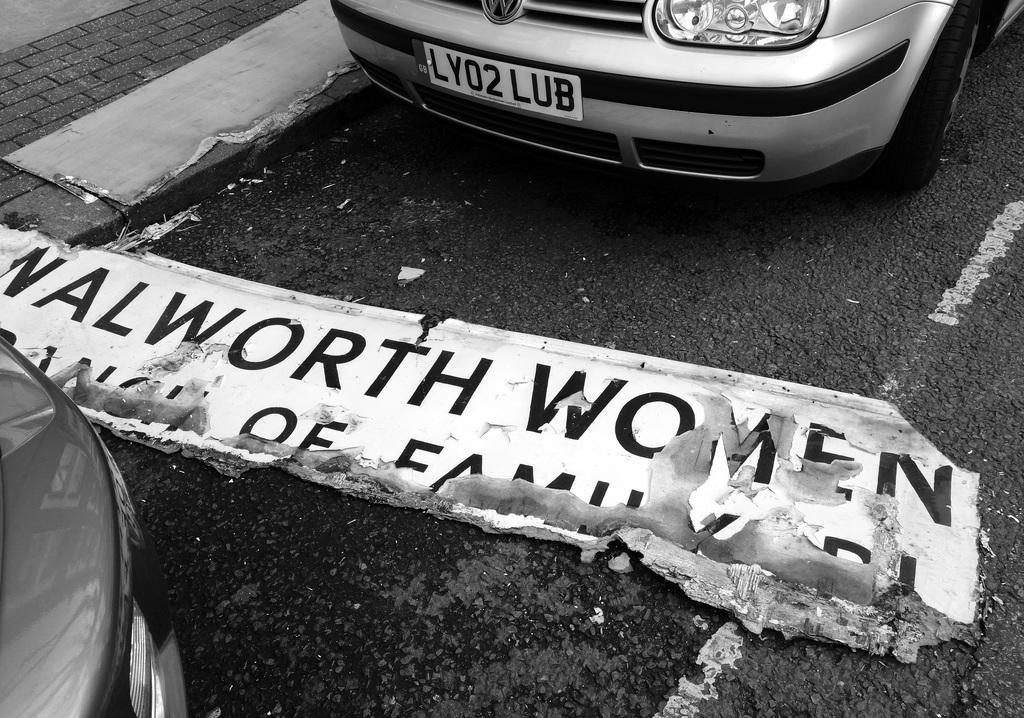Is it men or women mentioned on the sign on the ground?
Ensure brevity in your answer.  Women. What is the license plate number of the silver car?
Provide a short and direct response. Ly02 lub. 